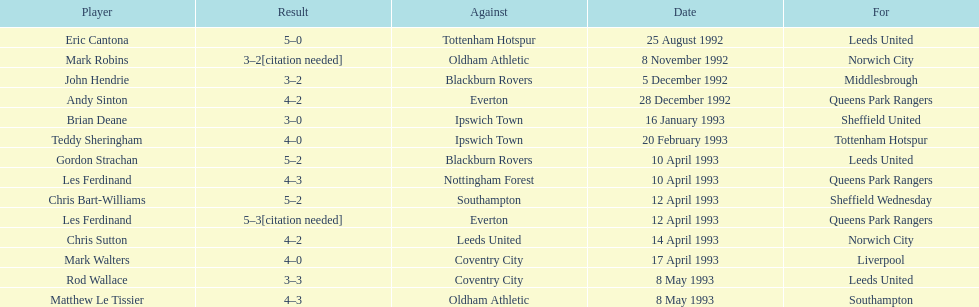What was the result of the match between queens park rangers and everton? 4-2. 